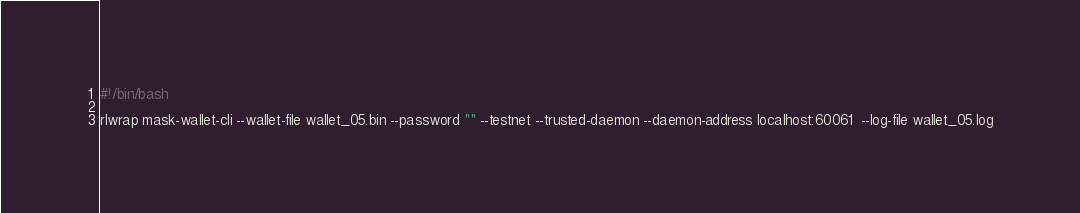<code> <loc_0><loc_0><loc_500><loc_500><_Bash_>#!/bin/bash

rlwrap mask-wallet-cli --wallet-file wallet_05.bin --password "" --testnet --trusted-daemon --daemon-address localhost:60061  --log-file wallet_05.log
</code> 